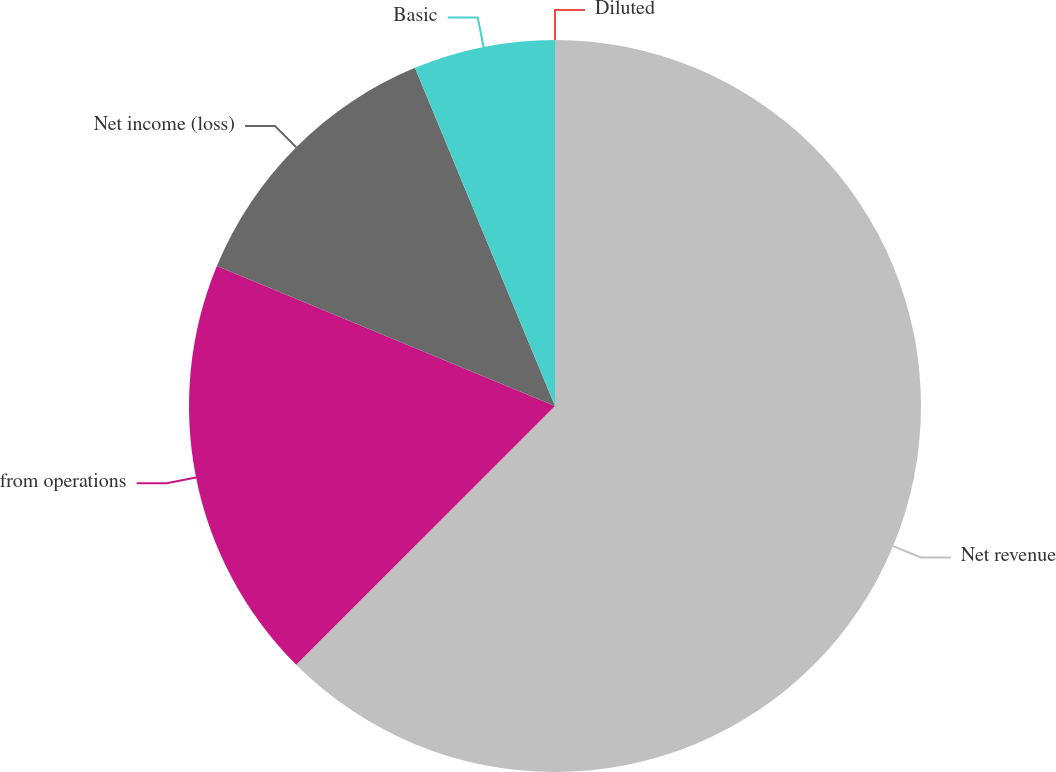Convert chart to OTSL. <chart><loc_0><loc_0><loc_500><loc_500><pie_chart><fcel>Net revenue<fcel>from operations<fcel>Net income (loss)<fcel>Basic<fcel>Diluted<nl><fcel>62.5%<fcel>18.75%<fcel>12.5%<fcel>6.25%<fcel>0.0%<nl></chart> 